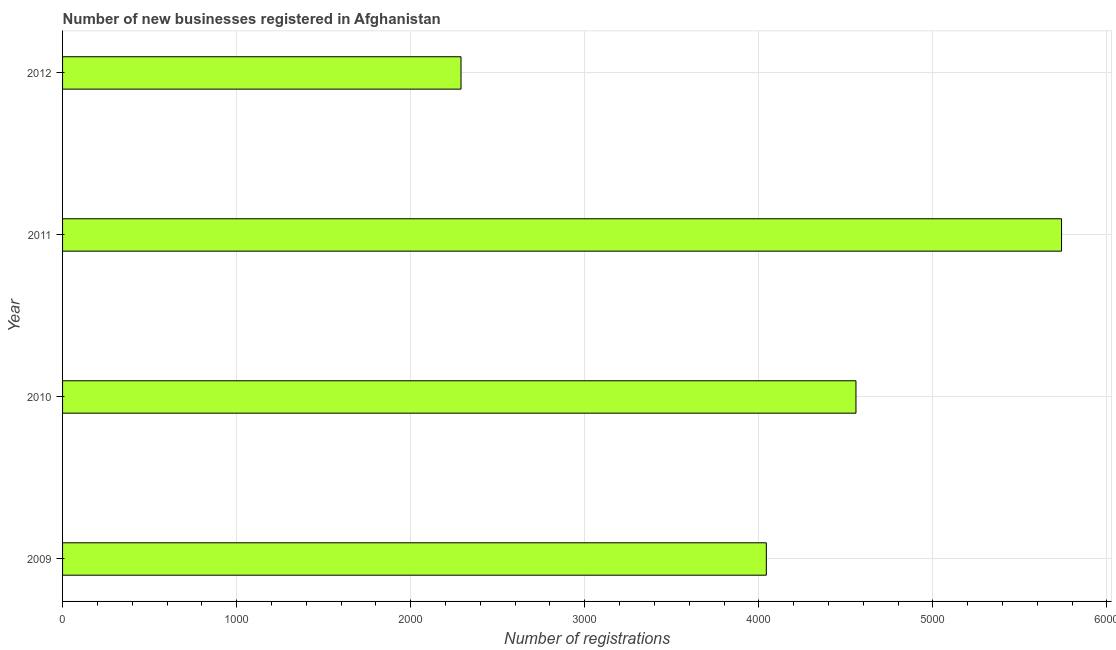Does the graph contain any zero values?
Offer a terse response. No. Does the graph contain grids?
Ensure brevity in your answer.  Yes. What is the title of the graph?
Keep it short and to the point. Number of new businesses registered in Afghanistan. What is the label or title of the X-axis?
Offer a very short reply. Number of registrations. What is the number of new business registrations in 2011?
Offer a very short reply. 5739. Across all years, what is the maximum number of new business registrations?
Provide a short and direct response. 5739. Across all years, what is the minimum number of new business registrations?
Your response must be concise. 2289. In which year was the number of new business registrations minimum?
Keep it short and to the point. 2012. What is the sum of the number of new business registrations?
Offer a terse response. 1.66e+04. What is the difference between the number of new business registrations in 2010 and 2011?
Your response must be concise. -1181. What is the average number of new business registrations per year?
Keep it short and to the point. 4157. What is the median number of new business registrations?
Your answer should be very brief. 4300.5. In how many years, is the number of new business registrations greater than 200 ?
Provide a succinct answer. 4. Do a majority of the years between 2011 and 2012 (inclusive) have number of new business registrations greater than 3800 ?
Offer a terse response. No. What is the ratio of the number of new business registrations in 2009 to that in 2010?
Provide a short and direct response. 0.89. Is the number of new business registrations in 2009 less than that in 2012?
Provide a short and direct response. No. What is the difference between the highest and the second highest number of new business registrations?
Provide a succinct answer. 1181. What is the difference between the highest and the lowest number of new business registrations?
Your answer should be compact. 3450. What is the difference between two consecutive major ticks on the X-axis?
Provide a succinct answer. 1000. Are the values on the major ticks of X-axis written in scientific E-notation?
Make the answer very short. No. What is the Number of registrations of 2009?
Provide a succinct answer. 4043. What is the Number of registrations in 2010?
Your answer should be compact. 4558. What is the Number of registrations in 2011?
Ensure brevity in your answer.  5739. What is the Number of registrations of 2012?
Your answer should be compact. 2289. What is the difference between the Number of registrations in 2009 and 2010?
Provide a succinct answer. -515. What is the difference between the Number of registrations in 2009 and 2011?
Keep it short and to the point. -1696. What is the difference between the Number of registrations in 2009 and 2012?
Your response must be concise. 1754. What is the difference between the Number of registrations in 2010 and 2011?
Give a very brief answer. -1181. What is the difference between the Number of registrations in 2010 and 2012?
Provide a succinct answer. 2269. What is the difference between the Number of registrations in 2011 and 2012?
Your response must be concise. 3450. What is the ratio of the Number of registrations in 2009 to that in 2010?
Ensure brevity in your answer.  0.89. What is the ratio of the Number of registrations in 2009 to that in 2011?
Provide a short and direct response. 0.7. What is the ratio of the Number of registrations in 2009 to that in 2012?
Your response must be concise. 1.77. What is the ratio of the Number of registrations in 2010 to that in 2011?
Offer a terse response. 0.79. What is the ratio of the Number of registrations in 2010 to that in 2012?
Your answer should be very brief. 1.99. What is the ratio of the Number of registrations in 2011 to that in 2012?
Your response must be concise. 2.51. 